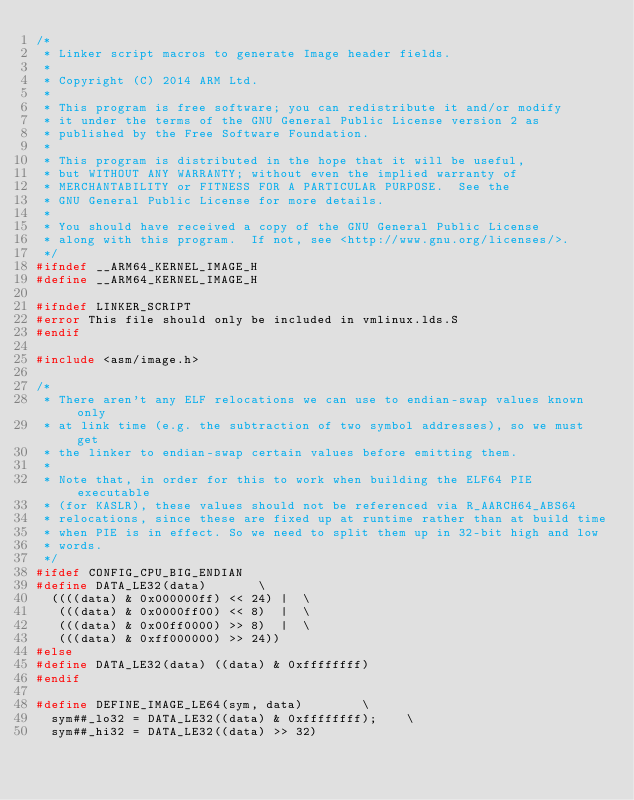<code> <loc_0><loc_0><loc_500><loc_500><_C_>/*
 * Linker script macros to generate Image header fields.
 *
 * Copyright (C) 2014 ARM Ltd.
 *
 * This program is free software; you can redistribute it and/or modify
 * it under the terms of the GNU General Public License version 2 as
 * published by the Free Software Foundation.
 *
 * This program is distributed in the hope that it will be useful,
 * but WITHOUT ANY WARRANTY; without even the implied warranty of
 * MERCHANTABILITY or FITNESS FOR A PARTICULAR PURPOSE.  See the
 * GNU General Public License for more details.
 *
 * You should have received a copy of the GNU General Public License
 * along with this program.  If not, see <http://www.gnu.org/licenses/>.
 */
#ifndef __ARM64_KERNEL_IMAGE_H
#define __ARM64_KERNEL_IMAGE_H

#ifndef LINKER_SCRIPT
#error This file should only be included in vmlinux.lds.S
#endif

#include <asm/image.h>

/*
 * There aren't any ELF relocations we can use to endian-swap values known only
 * at link time (e.g. the subtraction of two symbol addresses), so we must get
 * the linker to endian-swap certain values before emitting them.
 *
 * Note that, in order for this to work when building the ELF64 PIE executable
 * (for KASLR), these values should not be referenced via R_AARCH64_ABS64
 * relocations, since these are fixed up at runtime rather than at build time
 * when PIE is in effect. So we need to split them up in 32-bit high and low
 * words.
 */
#ifdef CONFIG_CPU_BIG_ENDIAN
#define DATA_LE32(data)				\
	((((data) & 0x000000ff) << 24) |	\
	 (((data) & 0x0000ff00) << 8)  |	\
	 (((data) & 0x00ff0000) >> 8)  |	\
	 (((data) & 0xff000000) >> 24))
#else
#define DATA_LE32(data) ((data) & 0xffffffff)
#endif

#define DEFINE_IMAGE_LE64(sym, data)				\
	sym##_lo32 = DATA_LE32((data) & 0xffffffff);		\
	sym##_hi32 = DATA_LE32((data) >> 32)
</code> 